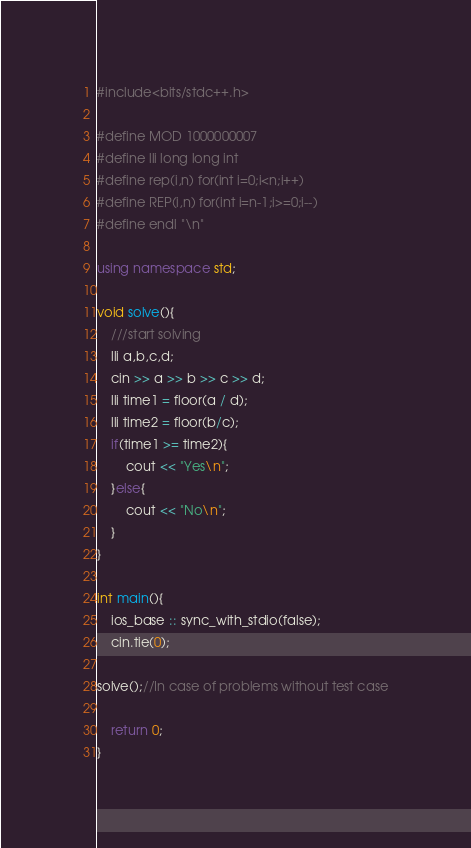Convert code to text. <code><loc_0><loc_0><loc_500><loc_500><_C++_>#include<bits/stdc++.h>

#define MOD 1000000007
#define lli long long int
#define rep(i,n) for(int i=0;i<n;i++)
#define REP(i,n) for(int i=n-1;i>=0;i--)
#define endl "\n"

using namespace std;

void solve(){
    ///start solving
	lli a,b,c,d;
	cin >> a >> b >> c >> d;
	lli time1 = floor(a / d);
	lli time2 = floor(b/c);
	if(time1 >= time2){
		cout << "Yes\n";
	}else{
		cout << "No\n";
	}
}

int main(){
    ios_base :: sync_with_stdio(false);
    cin.tie(0);
    
solve();//In case of problems without test case

	return 0;
}


</code> 